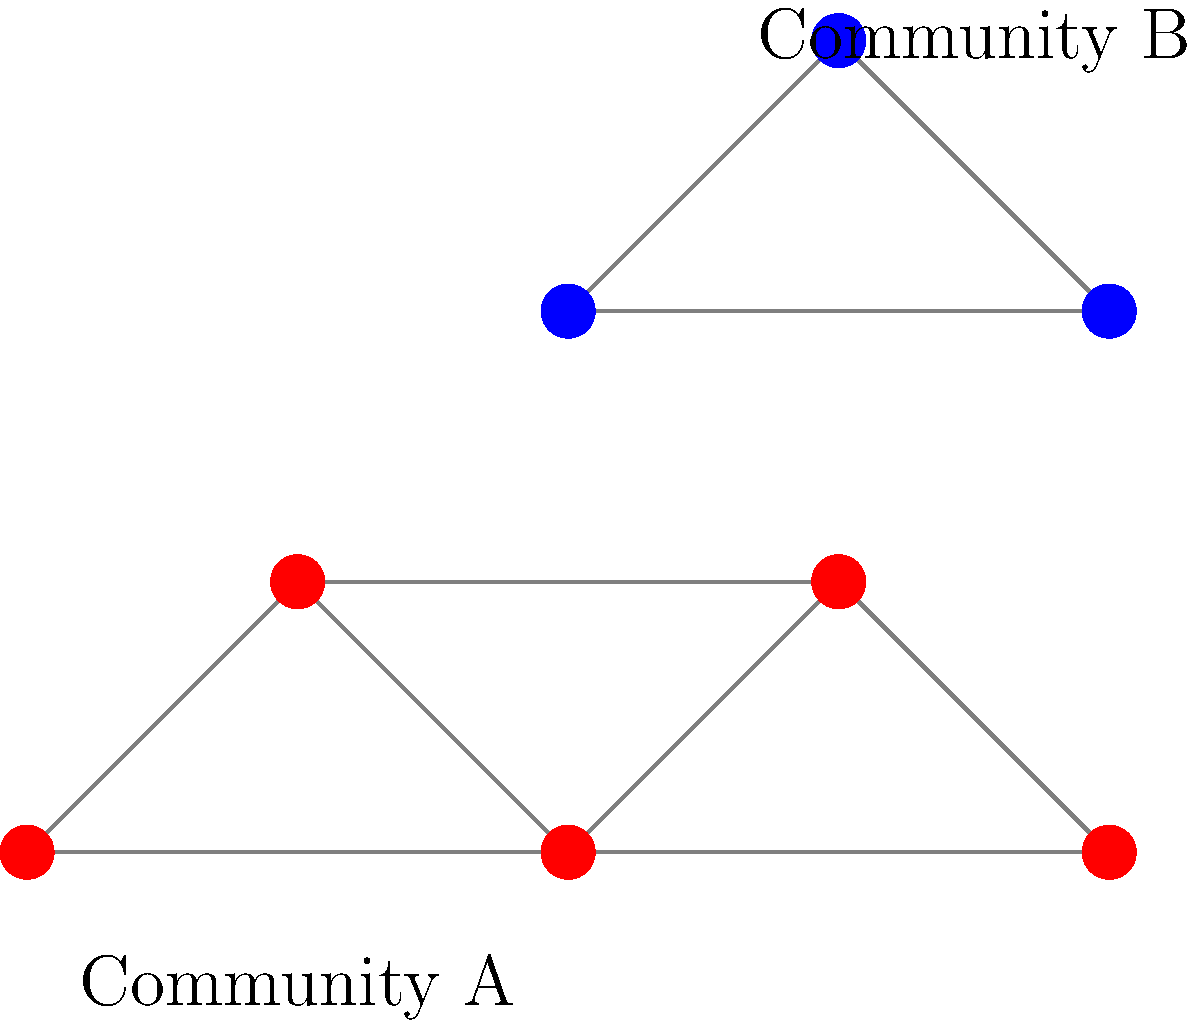In the social network of creative professionals shown above, two distinct communities are visible. What network analysis technique would be most appropriate for automatically detecting these communities, and what property of the network structure does it exploit? To answer this question, let's consider the steps a data scientist would take to analyze this network:

1. Observe the network structure: The graph shows two clear clusters of nodes, one with 5 red nodes (Community A) and another with 3 blue nodes (Community B).

2. Identify the key characteristic: The communities are distinguished by having more connections within the group than between groups.

3. Recall community detection algorithms: Several algorithms exist, but for this scenario, we need one that identifies densely connected subgraphs.

4. Choose the appropriate technique: The Louvain method is well-suited for this task because:
   a) It optimizes modularity, which measures the density of links inside communities compared to links between communities.
   b) It's efficient for large-scale networks, matching our scenario of a "large-scale social network."
   c) It doesn't require pre-specifying the number of communities, which is ideal for exploratory analysis.

5. Understand the property exploited: The Louvain method exploits the modularity of the network, which is higher when there are dense connections within communities and sparse connections between communities.

Therefore, the most appropriate technique is the Louvain method, which exploits the modularity property of the network structure to detect communities.
Answer: Louvain method; modularity 